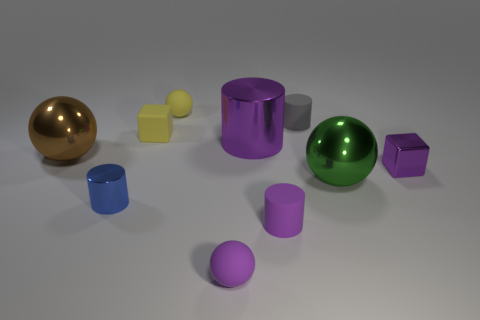Subtract all brown balls. How many balls are left? 3 Subtract all yellow balls. How many balls are left? 3 Subtract 0 gray cubes. How many objects are left? 10 Subtract all cylinders. How many objects are left? 6 Subtract 2 blocks. How many blocks are left? 0 Subtract all cyan spheres. Subtract all brown cubes. How many spheres are left? 4 Subtract all blue spheres. How many yellow cubes are left? 1 Subtract all small blue shiny cylinders. Subtract all big things. How many objects are left? 6 Add 6 small purple cylinders. How many small purple cylinders are left? 7 Add 10 tiny gray rubber blocks. How many tiny gray rubber blocks exist? 10 